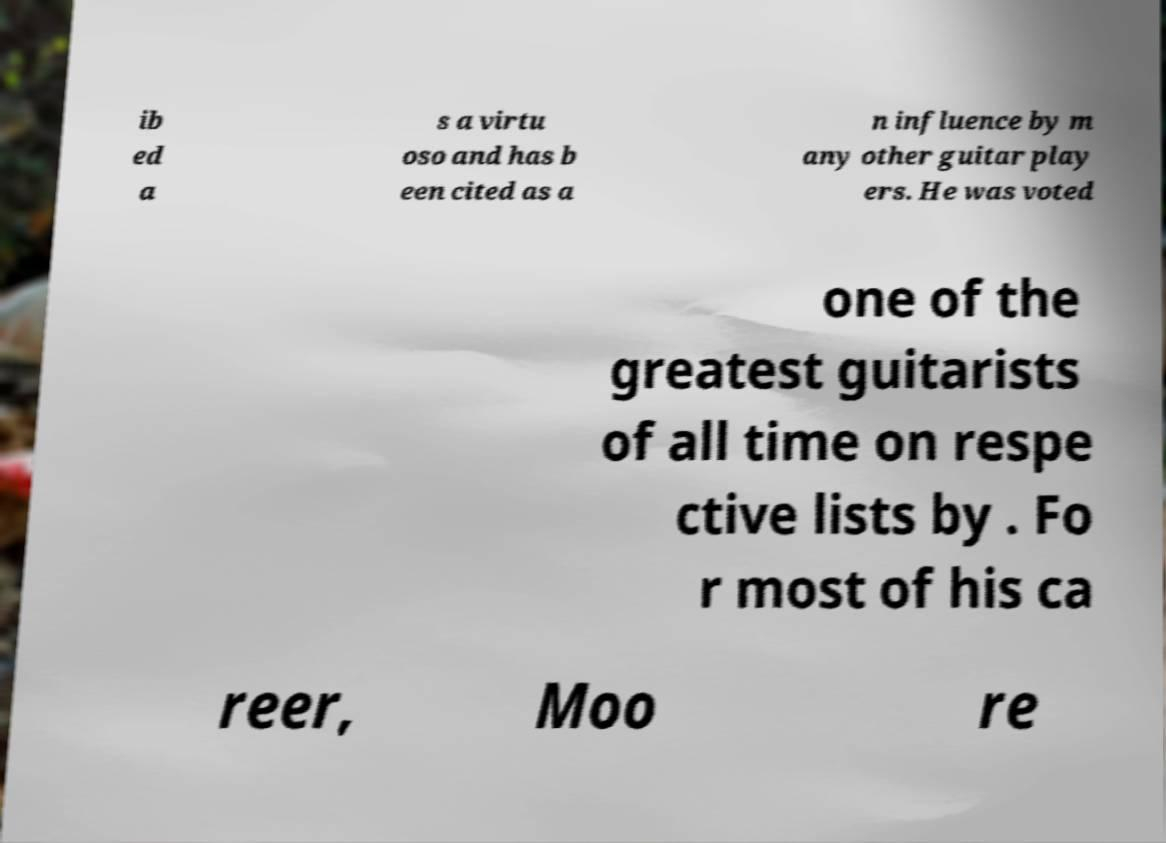Can you read and provide the text displayed in the image?This photo seems to have some interesting text. Can you extract and type it out for me? ib ed a s a virtu oso and has b een cited as a n influence by m any other guitar play ers. He was voted one of the greatest guitarists of all time on respe ctive lists by . Fo r most of his ca reer, Moo re 